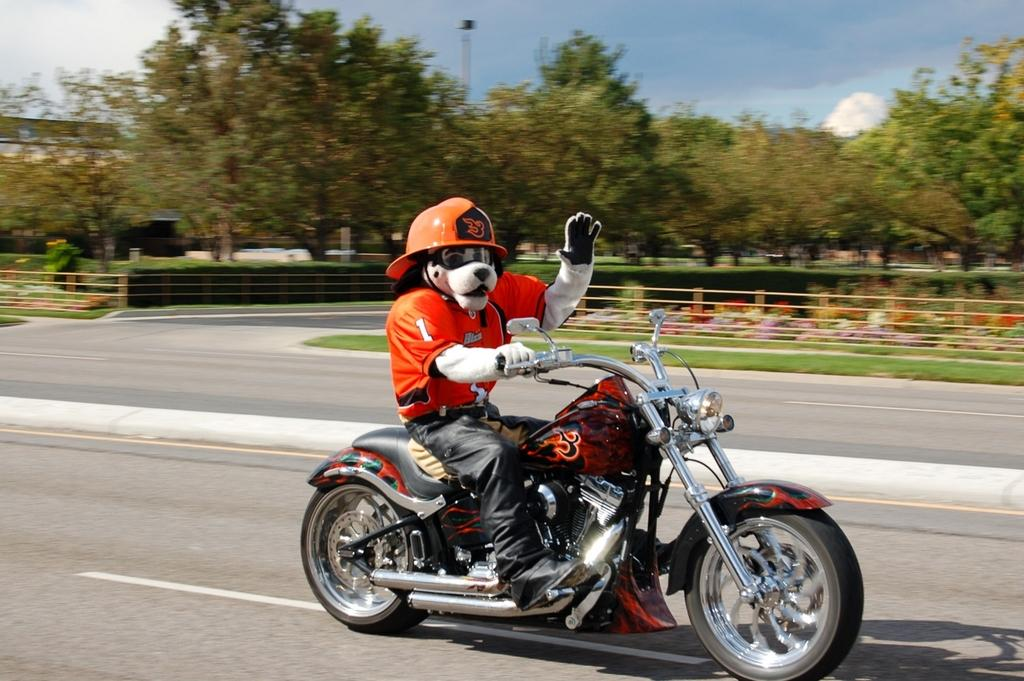What is the main subject in the foreground of the image? There is a man on a bike in the foreground of the image. What can be seen in the background of the image? There are trees, a railing, plants, flowers, and the sky visible in the background of the image. Can you describe the sky in the image? The sky is visible in the background of the image, and there is a cloud present. What type of carriage is being used for transport in the image? There is no carriage present in the image; the man is riding a bike. What rule is being enforced by the person in the image? There is no person enforcing any rule in the image; it features a man on a bike and various elements in the background. 